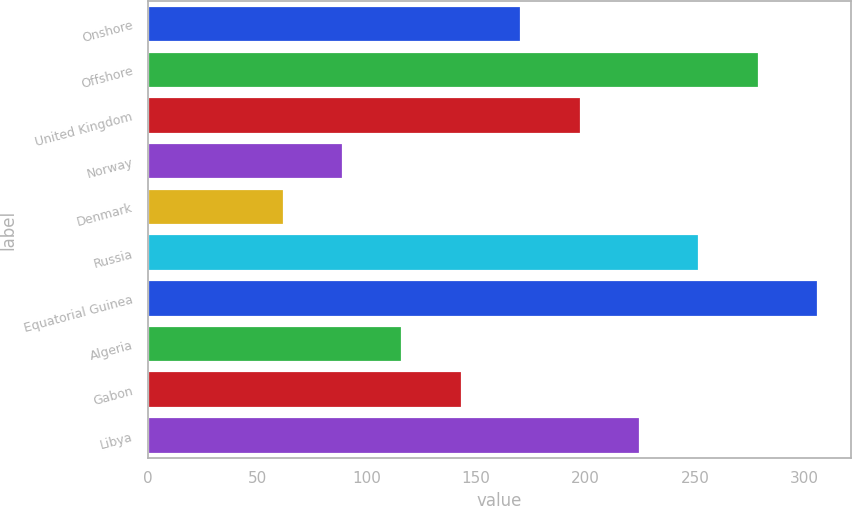<chart> <loc_0><loc_0><loc_500><loc_500><bar_chart><fcel>Onshore<fcel>Offshore<fcel>United Kingdom<fcel>Norway<fcel>Denmark<fcel>Russia<fcel>Equatorial Guinea<fcel>Algeria<fcel>Gabon<fcel>Libya<nl><fcel>170.6<fcel>279<fcel>197.7<fcel>89.3<fcel>62.2<fcel>251.9<fcel>306.1<fcel>116.4<fcel>143.5<fcel>224.8<nl></chart> 